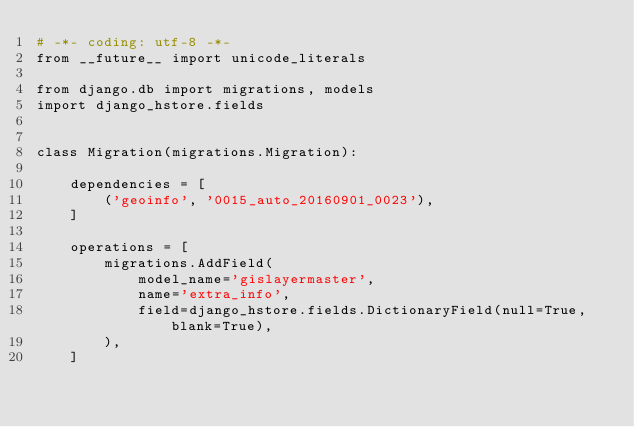<code> <loc_0><loc_0><loc_500><loc_500><_Python_># -*- coding: utf-8 -*-
from __future__ import unicode_literals

from django.db import migrations, models
import django_hstore.fields


class Migration(migrations.Migration):

    dependencies = [
        ('geoinfo', '0015_auto_20160901_0023'),
    ]

    operations = [
        migrations.AddField(
            model_name='gislayermaster',
            name='extra_info',
            field=django_hstore.fields.DictionaryField(null=True, blank=True),
        ),
    ]
</code> 